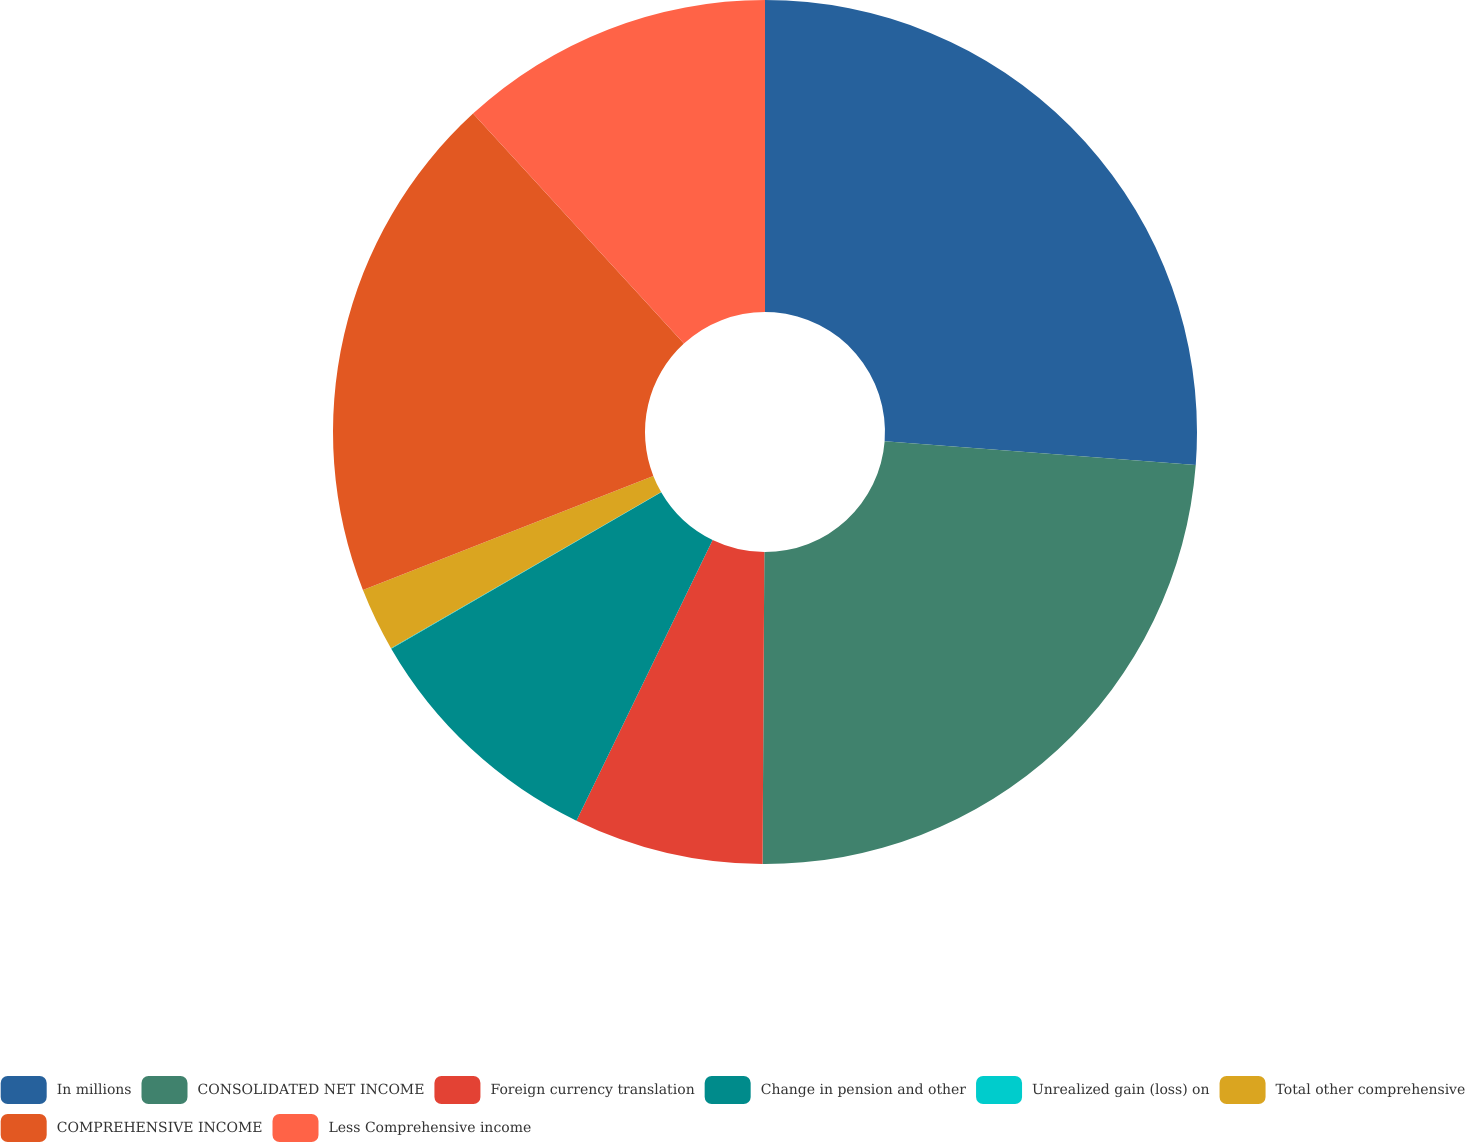<chart> <loc_0><loc_0><loc_500><loc_500><pie_chart><fcel>In millions<fcel>CONSOLIDATED NET INCOME<fcel>Foreign currency translation<fcel>Change in pension and other<fcel>Unrealized gain (loss) on<fcel>Total other comprehensive<fcel>COMPREHENSIVE INCOME<fcel>Less Comprehensive income<nl><fcel>26.22%<fcel>23.87%<fcel>7.1%<fcel>9.45%<fcel>0.02%<fcel>2.38%<fcel>19.15%<fcel>11.81%<nl></chart> 